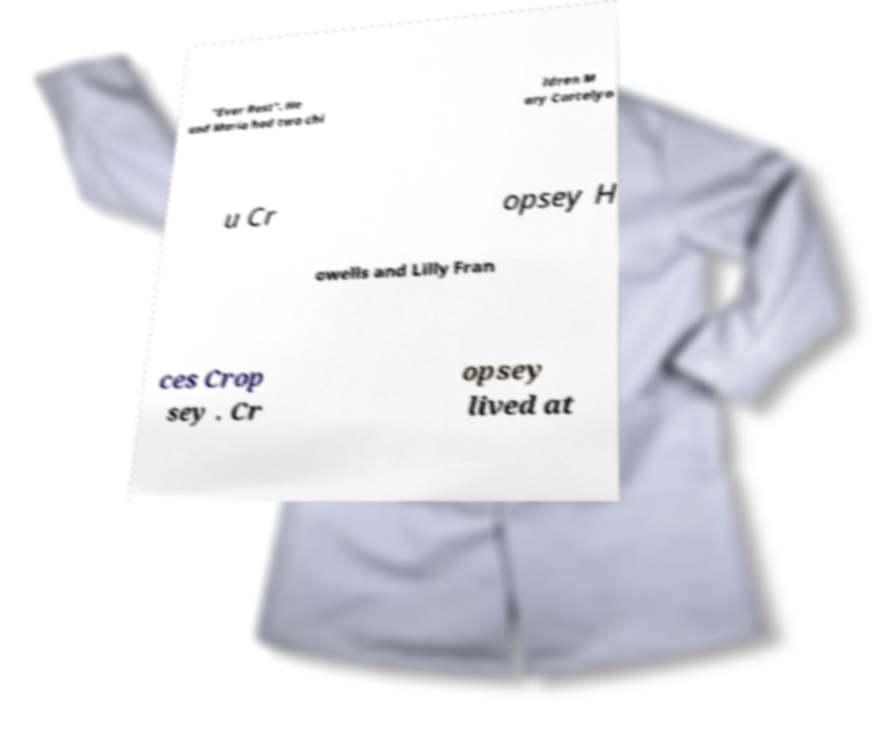Can you accurately transcribe the text from the provided image for me? "Ever Rest". He and Maria had two chi ldren M ary Cortelyo u Cr opsey H owells and Lilly Fran ces Crop sey . Cr opsey lived at 